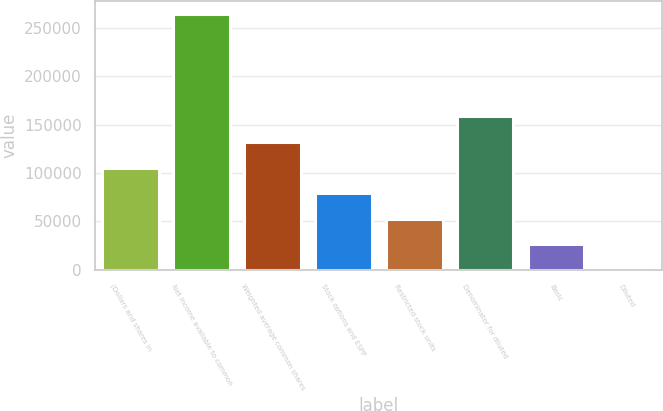Convert chart to OTSL. <chart><loc_0><loc_0><loc_500><loc_500><bar_chart><fcel>(Dollars and shares in<fcel>Net income available to common<fcel>Weighted average common shares<fcel>Stock options and ESPP<fcel>Restricted stock units<fcel>Denominator for diluted<fcel>Basic<fcel>Diluted<nl><fcel>105573<fcel>263925<fcel>131965<fcel>79181.2<fcel>52789.2<fcel>158357<fcel>26397.3<fcel>5.31<nl></chart> 